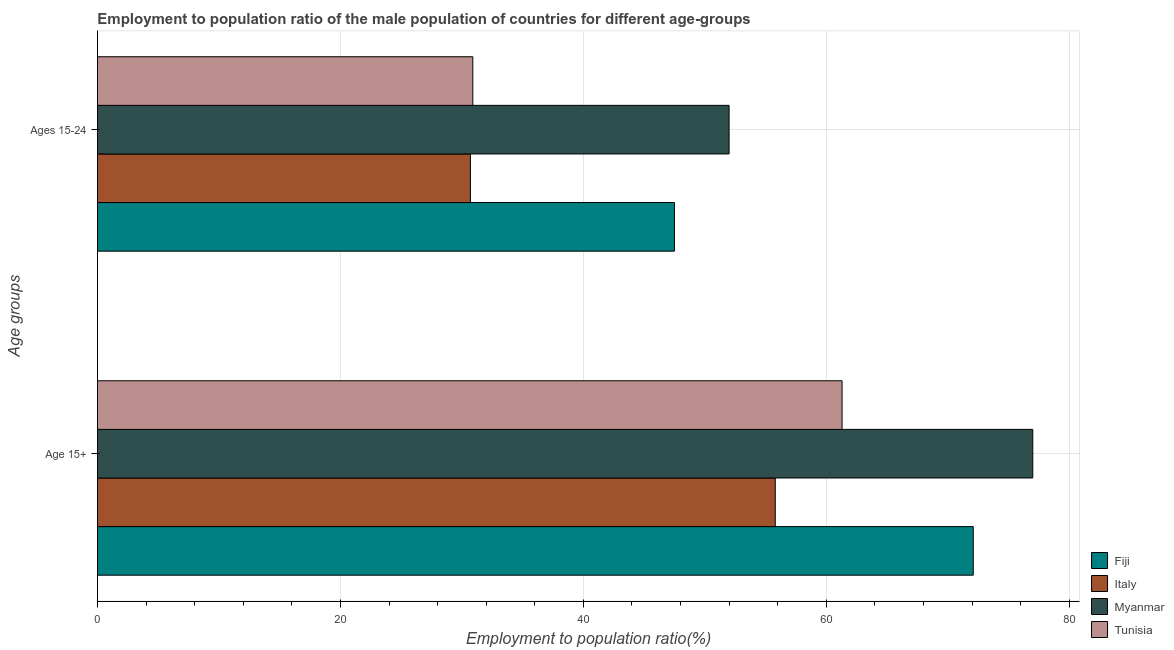How many different coloured bars are there?
Offer a terse response. 4. How many groups of bars are there?
Your answer should be compact. 2. Are the number of bars on each tick of the Y-axis equal?
Offer a very short reply. Yes. How many bars are there on the 1st tick from the top?
Provide a succinct answer. 4. What is the label of the 2nd group of bars from the top?
Keep it short and to the point. Age 15+. What is the employment to population ratio(age 15+) in Tunisia?
Offer a very short reply. 61.3. Across all countries, what is the maximum employment to population ratio(age 15-24)?
Provide a succinct answer. 52. Across all countries, what is the minimum employment to population ratio(age 15+)?
Offer a very short reply. 55.8. In which country was the employment to population ratio(age 15-24) maximum?
Offer a terse response. Myanmar. In which country was the employment to population ratio(age 15+) minimum?
Ensure brevity in your answer.  Italy. What is the total employment to population ratio(age 15-24) in the graph?
Your answer should be compact. 161.1. What is the difference between the employment to population ratio(age 15-24) in Myanmar and that in Fiji?
Offer a terse response. 4.5. What is the difference between the employment to population ratio(age 15-24) in Tunisia and the employment to population ratio(age 15+) in Fiji?
Provide a succinct answer. -41.2. What is the average employment to population ratio(age 15-24) per country?
Your response must be concise. 40.28. What is the difference between the employment to population ratio(age 15+) and employment to population ratio(age 15-24) in Fiji?
Your response must be concise. 24.6. In how many countries, is the employment to population ratio(age 15+) greater than 4 %?
Offer a very short reply. 4. What is the ratio of the employment to population ratio(age 15-24) in Myanmar to that in Italy?
Your answer should be compact. 1.69. What does the 4th bar from the top in Age 15+ represents?
Ensure brevity in your answer.  Fiji. What does the 4th bar from the bottom in Ages 15-24 represents?
Provide a succinct answer. Tunisia. Are all the bars in the graph horizontal?
Offer a terse response. Yes. How many countries are there in the graph?
Make the answer very short. 4. What is the difference between two consecutive major ticks on the X-axis?
Provide a short and direct response. 20. Are the values on the major ticks of X-axis written in scientific E-notation?
Give a very brief answer. No. Does the graph contain any zero values?
Provide a succinct answer. No. Where does the legend appear in the graph?
Offer a very short reply. Bottom right. How many legend labels are there?
Your answer should be compact. 4. How are the legend labels stacked?
Ensure brevity in your answer.  Vertical. What is the title of the graph?
Provide a succinct answer. Employment to population ratio of the male population of countries for different age-groups. Does "Bangladesh" appear as one of the legend labels in the graph?
Make the answer very short. No. What is the label or title of the X-axis?
Your response must be concise. Employment to population ratio(%). What is the label or title of the Y-axis?
Your response must be concise. Age groups. What is the Employment to population ratio(%) of Fiji in Age 15+?
Your answer should be compact. 72.1. What is the Employment to population ratio(%) of Italy in Age 15+?
Give a very brief answer. 55.8. What is the Employment to population ratio(%) of Myanmar in Age 15+?
Your response must be concise. 77. What is the Employment to population ratio(%) in Tunisia in Age 15+?
Make the answer very short. 61.3. What is the Employment to population ratio(%) of Fiji in Ages 15-24?
Ensure brevity in your answer.  47.5. What is the Employment to population ratio(%) in Italy in Ages 15-24?
Your answer should be very brief. 30.7. What is the Employment to population ratio(%) of Tunisia in Ages 15-24?
Ensure brevity in your answer.  30.9. Across all Age groups, what is the maximum Employment to population ratio(%) of Fiji?
Offer a terse response. 72.1. Across all Age groups, what is the maximum Employment to population ratio(%) in Italy?
Offer a very short reply. 55.8. Across all Age groups, what is the maximum Employment to population ratio(%) of Myanmar?
Your response must be concise. 77. Across all Age groups, what is the maximum Employment to population ratio(%) of Tunisia?
Your answer should be very brief. 61.3. Across all Age groups, what is the minimum Employment to population ratio(%) in Fiji?
Provide a short and direct response. 47.5. Across all Age groups, what is the minimum Employment to population ratio(%) of Italy?
Provide a succinct answer. 30.7. Across all Age groups, what is the minimum Employment to population ratio(%) of Myanmar?
Provide a short and direct response. 52. Across all Age groups, what is the minimum Employment to population ratio(%) in Tunisia?
Give a very brief answer. 30.9. What is the total Employment to population ratio(%) in Fiji in the graph?
Offer a terse response. 119.6. What is the total Employment to population ratio(%) in Italy in the graph?
Offer a very short reply. 86.5. What is the total Employment to population ratio(%) in Myanmar in the graph?
Keep it short and to the point. 129. What is the total Employment to population ratio(%) of Tunisia in the graph?
Keep it short and to the point. 92.2. What is the difference between the Employment to population ratio(%) of Fiji in Age 15+ and that in Ages 15-24?
Keep it short and to the point. 24.6. What is the difference between the Employment to population ratio(%) of Italy in Age 15+ and that in Ages 15-24?
Offer a very short reply. 25.1. What is the difference between the Employment to population ratio(%) in Tunisia in Age 15+ and that in Ages 15-24?
Your response must be concise. 30.4. What is the difference between the Employment to population ratio(%) of Fiji in Age 15+ and the Employment to population ratio(%) of Italy in Ages 15-24?
Give a very brief answer. 41.4. What is the difference between the Employment to population ratio(%) of Fiji in Age 15+ and the Employment to population ratio(%) of Myanmar in Ages 15-24?
Your answer should be compact. 20.1. What is the difference between the Employment to population ratio(%) in Fiji in Age 15+ and the Employment to population ratio(%) in Tunisia in Ages 15-24?
Your response must be concise. 41.2. What is the difference between the Employment to population ratio(%) of Italy in Age 15+ and the Employment to population ratio(%) of Tunisia in Ages 15-24?
Your response must be concise. 24.9. What is the difference between the Employment to population ratio(%) of Myanmar in Age 15+ and the Employment to population ratio(%) of Tunisia in Ages 15-24?
Give a very brief answer. 46.1. What is the average Employment to population ratio(%) of Fiji per Age groups?
Your response must be concise. 59.8. What is the average Employment to population ratio(%) of Italy per Age groups?
Give a very brief answer. 43.25. What is the average Employment to population ratio(%) of Myanmar per Age groups?
Make the answer very short. 64.5. What is the average Employment to population ratio(%) of Tunisia per Age groups?
Give a very brief answer. 46.1. What is the difference between the Employment to population ratio(%) of Fiji and Employment to population ratio(%) of Myanmar in Age 15+?
Your answer should be very brief. -4.9. What is the difference between the Employment to population ratio(%) in Italy and Employment to population ratio(%) in Myanmar in Age 15+?
Offer a terse response. -21.2. What is the difference between the Employment to population ratio(%) of Italy and Employment to population ratio(%) of Tunisia in Age 15+?
Offer a terse response. -5.5. What is the difference between the Employment to population ratio(%) in Fiji and Employment to population ratio(%) in Italy in Ages 15-24?
Ensure brevity in your answer.  16.8. What is the difference between the Employment to population ratio(%) of Fiji and Employment to population ratio(%) of Myanmar in Ages 15-24?
Provide a short and direct response. -4.5. What is the difference between the Employment to population ratio(%) in Italy and Employment to population ratio(%) in Myanmar in Ages 15-24?
Offer a terse response. -21.3. What is the difference between the Employment to population ratio(%) in Italy and Employment to population ratio(%) in Tunisia in Ages 15-24?
Ensure brevity in your answer.  -0.2. What is the difference between the Employment to population ratio(%) of Myanmar and Employment to population ratio(%) of Tunisia in Ages 15-24?
Offer a terse response. 21.1. What is the ratio of the Employment to population ratio(%) of Fiji in Age 15+ to that in Ages 15-24?
Provide a succinct answer. 1.52. What is the ratio of the Employment to population ratio(%) of Italy in Age 15+ to that in Ages 15-24?
Ensure brevity in your answer.  1.82. What is the ratio of the Employment to population ratio(%) of Myanmar in Age 15+ to that in Ages 15-24?
Provide a short and direct response. 1.48. What is the ratio of the Employment to population ratio(%) of Tunisia in Age 15+ to that in Ages 15-24?
Provide a succinct answer. 1.98. What is the difference between the highest and the second highest Employment to population ratio(%) of Fiji?
Provide a short and direct response. 24.6. What is the difference between the highest and the second highest Employment to population ratio(%) in Italy?
Ensure brevity in your answer.  25.1. What is the difference between the highest and the second highest Employment to population ratio(%) in Tunisia?
Give a very brief answer. 30.4. What is the difference between the highest and the lowest Employment to population ratio(%) of Fiji?
Provide a succinct answer. 24.6. What is the difference between the highest and the lowest Employment to population ratio(%) of Italy?
Make the answer very short. 25.1. What is the difference between the highest and the lowest Employment to population ratio(%) of Myanmar?
Your answer should be very brief. 25. What is the difference between the highest and the lowest Employment to population ratio(%) of Tunisia?
Provide a succinct answer. 30.4. 